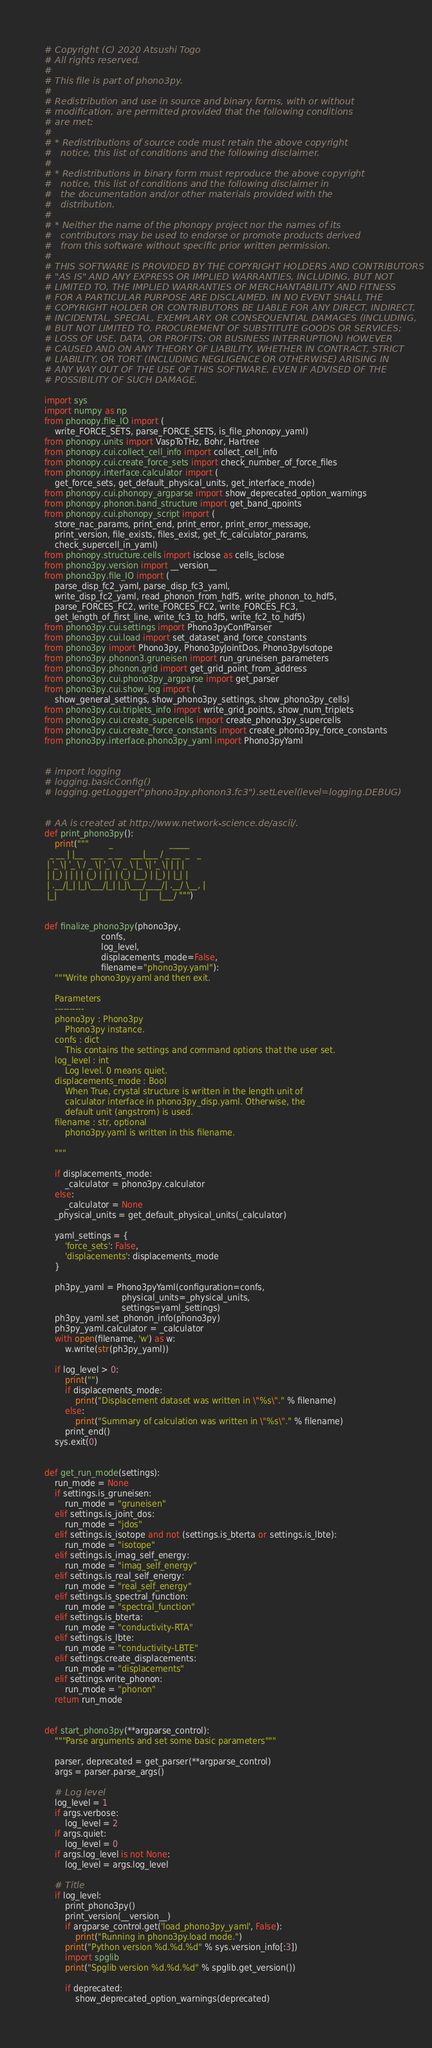<code> <loc_0><loc_0><loc_500><loc_500><_Python_># Copyright (C) 2020 Atsushi Togo
# All rights reserved.
#
# This file is part of phono3py.
#
# Redistribution and use in source and binary forms, with or without
# modification, are permitted provided that the following conditions
# are met:
#
# * Redistributions of source code must retain the above copyright
#   notice, this list of conditions and the following disclaimer.
#
# * Redistributions in binary form must reproduce the above copyright
#   notice, this list of conditions and the following disclaimer in
#   the documentation and/or other materials provided with the
#   distribution.
#
# * Neither the name of the phonopy project nor the names of its
#   contributors may be used to endorse or promote products derived
#   from this software without specific prior written permission.
#
# THIS SOFTWARE IS PROVIDED BY THE COPYRIGHT HOLDERS AND CONTRIBUTORS
# "AS IS" AND ANY EXPRESS OR IMPLIED WARRANTIES, INCLUDING, BUT NOT
# LIMITED TO, THE IMPLIED WARRANTIES OF MERCHANTABILITY AND FITNESS
# FOR A PARTICULAR PURPOSE ARE DISCLAIMED. IN NO EVENT SHALL THE
# COPYRIGHT HOLDER OR CONTRIBUTORS BE LIABLE FOR ANY DIRECT, INDIRECT,
# INCIDENTAL, SPECIAL, EXEMPLARY, OR CONSEQUENTIAL DAMAGES (INCLUDING,
# BUT NOT LIMITED TO, PROCUREMENT OF SUBSTITUTE GOODS OR SERVICES;
# LOSS OF USE, DATA, OR PROFITS; OR BUSINESS INTERRUPTION) HOWEVER
# CAUSED AND ON ANY THEORY OF LIABILITY, WHETHER IN CONTRACT, STRICT
# LIABILITY, OR TORT (INCLUDING NEGLIGENCE OR OTHERWISE) ARISING IN
# ANY WAY OUT OF THE USE OF THIS SOFTWARE, EVEN IF ADVISED OF THE
# POSSIBILITY OF SUCH DAMAGE.

import sys
import numpy as np
from phonopy.file_IO import (
    write_FORCE_SETS, parse_FORCE_SETS, is_file_phonopy_yaml)
from phonopy.units import VaspToTHz, Bohr, Hartree
from phonopy.cui.collect_cell_info import collect_cell_info
from phonopy.cui.create_force_sets import check_number_of_force_files
from phonopy.interface.calculator import (
    get_force_sets, get_default_physical_units, get_interface_mode)
from phonopy.cui.phonopy_argparse import show_deprecated_option_warnings
from phonopy.phonon.band_structure import get_band_qpoints
from phonopy.cui.phonopy_script import (
    store_nac_params, print_end, print_error, print_error_message,
    print_version, file_exists, files_exist, get_fc_calculator_params,
    check_supercell_in_yaml)
from phonopy.structure.cells import isclose as cells_isclose
from phono3py.version import __version__
from phono3py.file_IO import (
    parse_disp_fc2_yaml, parse_disp_fc3_yaml,
    write_disp_fc2_yaml, read_phonon_from_hdf5, write_phonon_to_hdf5,
    parse_FORCES_FC2, write_FORCES_FC2, write_FORCES_FC3,
    get_length_of_first_line, write_fc3_to_hdf5, write_fc2_to_hdf5)
from phono3py.cui.settings import Phono3pyConfParser
from phono3py.cui.load import set_dataset_and_force_constants
from phono3py import Phono3py, Phono3pyJointDos, Phono3pyIsotope
from phono3py.phonon3.gruneisen import run_gruneisen_parameters
from phono3py.phonon.grid import get_grid_point_from_address
from phono3py.cui.phono3py_argparse import get_parser
from phono3py.cui.show_log import (
    show_general_settings, show_phono3py_settings, show_phono3py_cells)
from phono3py.cui.triplets_info import write_grid_points, show_num_triplets
from phono3py.cui.create_supercells import create_phono3py_supercells
from phono3py.cui.create_force_constants import create_phono3py_force_constants
from phono3py.interface.phono3py_yaml import Phono3pyYaml


# import logging
# logging.basicConfig()
# logging.getLogger("phono3py.phonon3.fc3").setLevel(level=logging.DEBUG)


# AA is created at http://www.network-science.de/ascii/.
def print_phono3py():
    print("""        _                      _____
  _ __ | |__   ___  _ __   ___|___ / _ __  _   _
 | '_ \| '_ \ / _ \| '_ \ / _ \ |_ \| '_ \| | | |
 | |_) | | | | (_) | | | | (_) |__) | |_) | |_| |
 | .__/|_| |_|\___/|_| |_|\___/____/| .__/ \__, |
 |_|                                |_|    |___/ """)


def finalize_phono3py(phono3py,
                      confs,
                      log_level,
                      displacements_mode=False,
                      filename="phono3py.yaml"):
    """Write phono3py.yaml and then exit.

    Parameters
    ----------
    phono3py : Phono3py
        Phono3py instance.
    confs : dict
        This contains the settings and command options that the user set.
    log_level : int
        Log level. 0 means quiet.
    displacements_mode : Bool
        When True, crystal structure is written in the length unit of
        calculator interface in phono3py_disp.yaml. Otherwise, the
        default unit (angstrom) is used.
    filename : str, optional
        phono3py.yaml is written in this filename.

    """

    if displacements_mode:
        _calculator = phono3py.calculator
    else:
        _calculator = None
    _physical_units = get_default_physical_units(_calculator)

    yaml_settings = {
        'force_sets': False,
        'displacements': displacements_mode
    }

    ph3py_yaml = Phono3pyYaml(configuration=confs,
                              physical_units=_physical_units,
                              settings=yaml_settings)
    ph3py_yaml.set_phonon_info(phono3py)
    ph3py_yaml.calculator = _calculator
    with open(filename, 'w') as w:
        w.write(str(ph3py_yaml))

    if log_level > 0:
        print("")
        if displacements_mode:
            print("Displacement dataset was written in \"%s\"." % filename)
        else:
            print("Summary of calculation was written in \"%s\"." % filename)
        print_end()
    sys.exit(0)


def get_run_mode(settings):
    run_mode = None
    if settings.is_gruneisen:
        run_mode = "gruneisen"
    elif settings.is_joint_dos:
        run_mode = "jdos"
    elif settings.is_isotope and not (settings.is_bterta or settings.is_lbte):
        run_mode = "isotope"
    elif settings.is_imag_self_energy:
        run_mode = "imag_self_energy"
    elif settings.is_real_self_energy:
        run_mode = "real_self_energy"
    elif settings.is_spectral_function:
        run_mode = "spectral_function"
    elif settings.is_bterta:
        run_mode = "conductivity-RTA"
    elif settings.is_lbte:
        run_mode = "conductivity-LBTE"
    elif settings.create_displacements:
        run_mode = "displacements"
    elif settings.write_phonon:
        run_mode = "phonon"
    return run_mode


def start_phono3py(**argparse_control):
    """Parse arguments and set some basic parameters"""

    parser, deprecated = get_parser(**argparse_control)
    args = parser.parse_args()

    # Log level
    log_level = 1
    if args.verbose:
        log_level = 2
    if args.quiet:
        log_level = 0
    if args.log_level is not None:
        log_level = args.log_level

    # Title
    if log_level:
        print_phono3py()
        print_version(__version__)
        if argparse_control.get('load_phono3py_yaml', False):
            print("Running in phono3py.load mode.")
        print("Python version %d.%d.%d" % sys.version_info[:3])
        import spglib
        print("Spglib version %d.%d.%d" % spglib.get_version())

        if deprecated:
            show_deprecated_option_warnings(deprecated)
</code> 